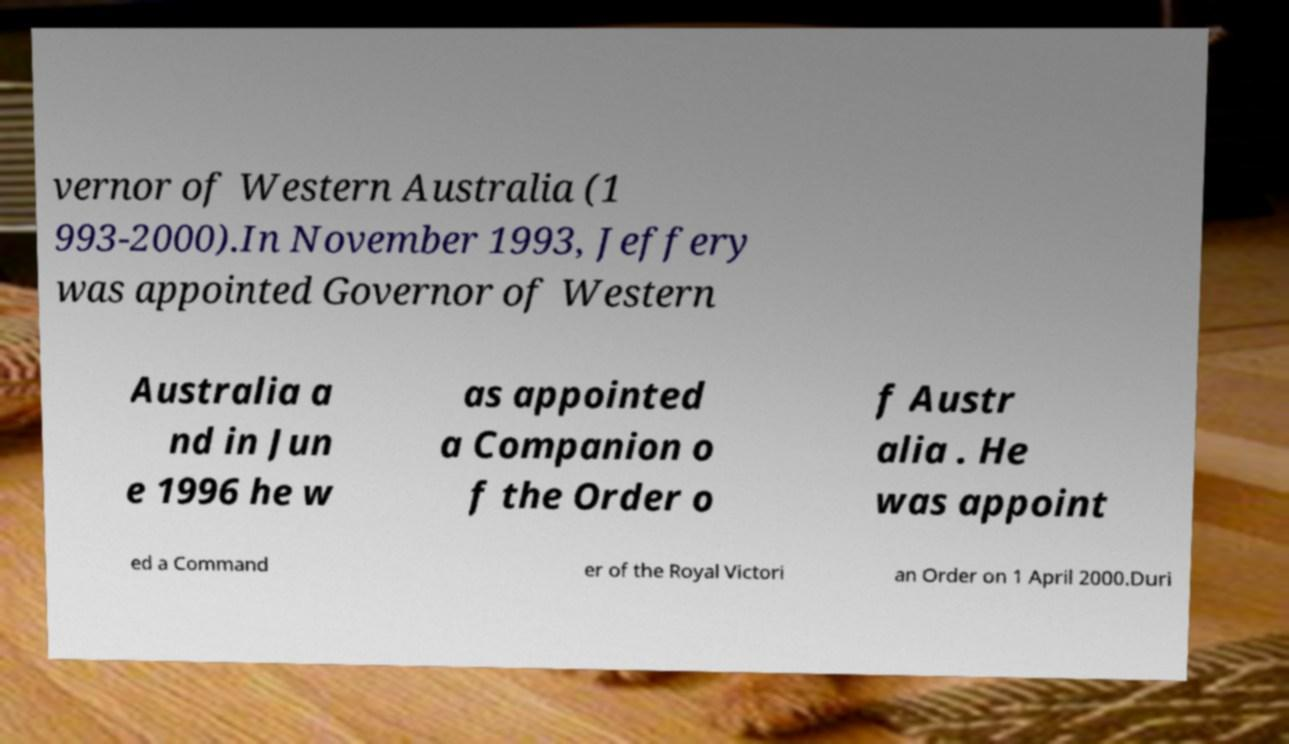For documentation purposes, I need the text within this image transcribed. Could you provide that? vernor of Western Australia (1 993-2000).In November 1993, Jeffery was appointed Governor of Western Australia a nd in Jun e 1996 he w as appointed a Companion o f the Order o f Austr alia . He was appoint ed a Command er of the Royal Victori an Order on 1 April 2000.Duri 